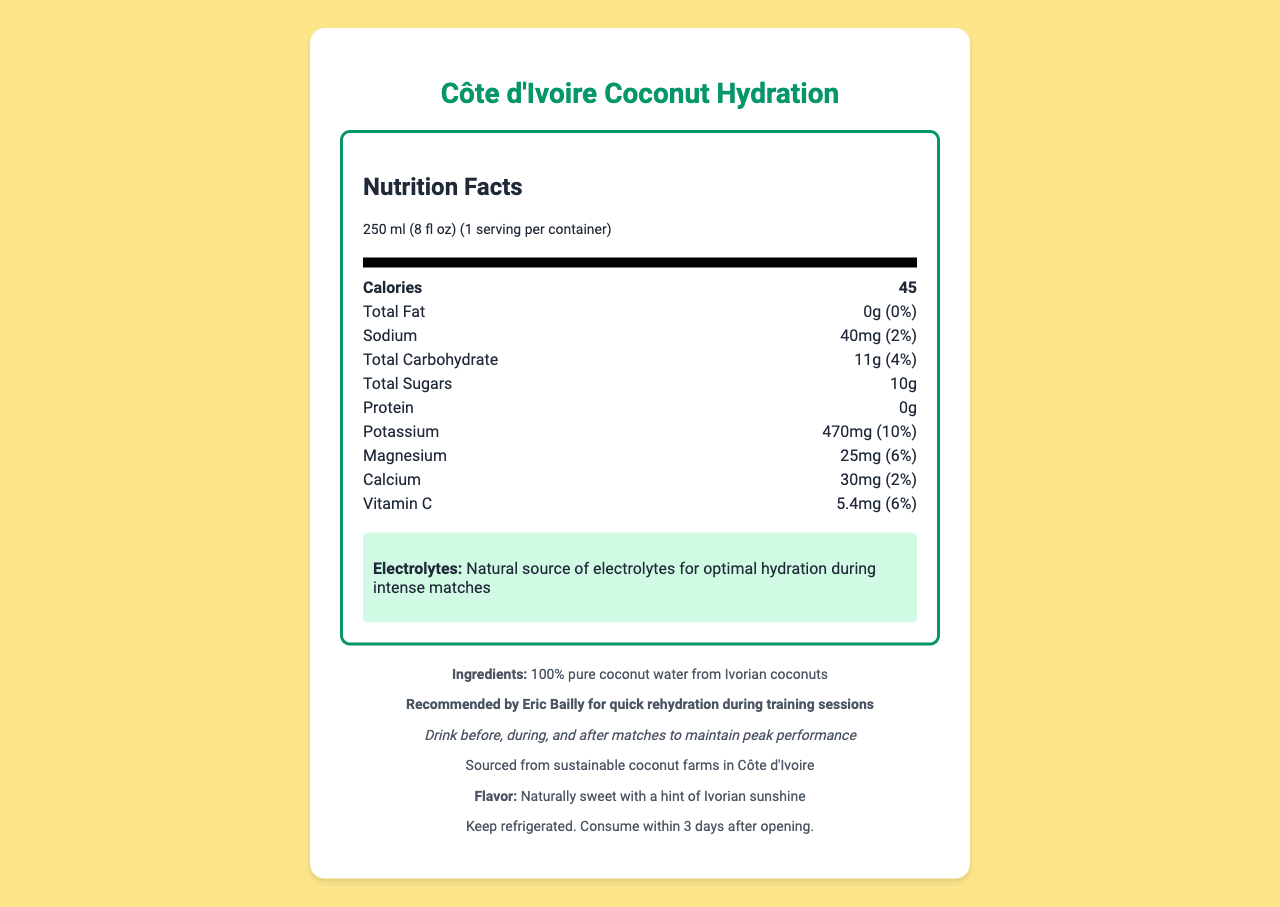what is the serving size for Côte d'Ivoire Coconut Hydration? The serving size is clearly mentioned under the "serving info" section of the nutrition label.
Answer: 250 ml (8 fl oz) how many calories are in one serving? The number of calories is displayed prominently in the "nutrition item" section for calories.
Answer: 45 how much potassium does one serving contain? The amount of potassium is listed under the "nutrition item" section for potassium.
Answer: 470mg what is the daily value percentage of magnesium? The daily value percentage for magnesium is given next to the amount of magnesium in the "nutrition item" section.
Answer: 6% what is the recommended storage instruction? The storage instructions are mentioned at the bottom of the document in the footer section.
Answer: Keep refrigerated. Consume within 3 days after opening. how much sodium does one serving contain? A. 20mg B. 40mg C. 60mg D. 80mg The amount of sodium per serving is listed in the "nutrition item" section for sodium.
Answer: B. 40mg what is the main source of hydration in Côte d'Ivoire Coconut Hydration? A. Added sugars B. Artificial flavors C. Pure coconut water D. Processed water It is highlighted that the product is made of 100% pure coconut water from Ivorian coconuts in the ingredients section.
Answer: C. Pure coconut water does Eric Bailly recommend this product for quick rehydration during training sessions? This endorsement is specifically mentioned in the footer section of the document.
Answer: Yes what is the total amount of sugars in one serving? The total amount of sugars is mentioned in the "nutrition item" section for total sugars.
Answer: 10g is the sustainability of the coconut farms mentioned? The document states that the product is sourced from sustainable coconut farms in Côte d'Ivoire.
Answer: Yes describe the main idea of the document. The document contains comprehensive information on the nutritional value, storage instructions, endorsements, and sustainability notes for Côte d'Ivoire Coconut Hydration, emphasizing its role in sports hydration.
Answer: The document provides detailed nutrition facts about Côte d'Ivoire Coconut Hydration, highlighting its electrolyte content and other nutritional information. It emphasizes the product's benefits for hydration, particularly for athletes, and includes endorsements from footballer Eric Bailly. Additionally, it mentions that the coconut water is sustainably sourced from Ivorian farms. how much calcium does one serving have? The amount of calcium is listed in the "nutrition item" section for calcium.
Answer: 30mg what can be inferred about the flavor of Côte d'Ivoire Coconut Hydration? The flavor profile is directly mentioned in the footer section of the document.
Answer: Naturally sweet with a hint of Ivorian sunshine is the product recommended to drink only before matches? The match day tip suggests drinking the product before, during, and after matches to maintain peak performance.
Answer: No what is the specific role of electrolytes mentioned in the document? The document states that the product is a natural source of electrolytes for optimal hydration during intense matches.
Answer: Optimal hydration during intense matches what is the exact amount of vitamin C in one serving? The amount of vitamin C is mentioned in the "nutrition item" section for vitamin C.
Answer: 5.4mg which mineral has the highest daily value percentage in one serving? A. Sodium B. Calcium C. Potassium D. Magnesium The daily value percentage for potassium is 10%, which is higher than that of other mentioned minerals like sodium (2%), calcium (2%), and magnesium (6%).
Answer: C. Potassium is there any information about the shelf life of the product before opening? The document only provides storage instructions for after the container has been opened, with no details about the shelf life before opening.
Answer: Not enough information 